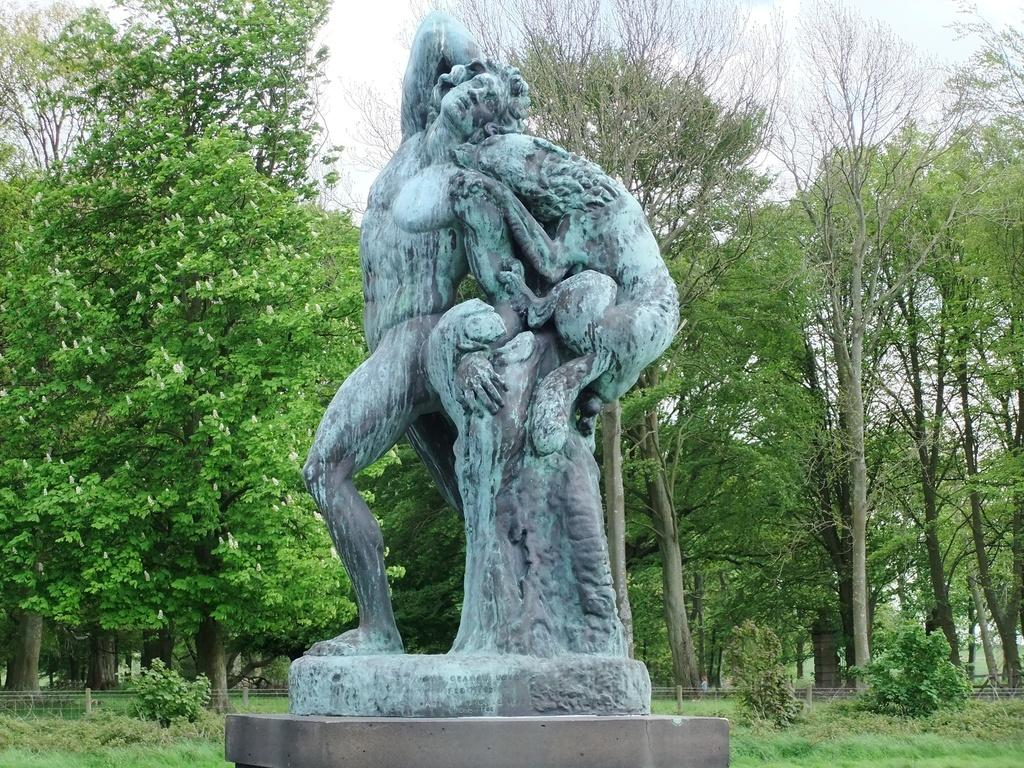What is the main subject in the center of the image? There is a statue in the center of the image. What can be seen in the background of the image? There are trees, grass, plants, and the sky visible in the background of the image. What type of cart is being used for the meeting in the image? There is no cart or meeting present in the image; it features a statue and natural elements in the background. 